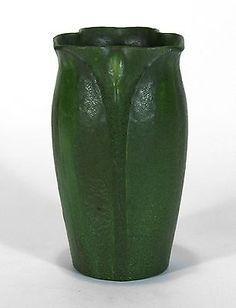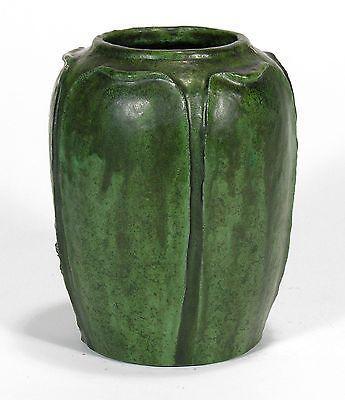The first image is the image on the left, the second image is the image on the right. Evaluate the accuracy of this statement regarding the images: "All vases are the same green color with a drip effect, and no vases have handles.". Is it true? Answer yes or no. Yes. The first image is the image on the left, the second image is the image on the right. Examine the images to the left and right. Is the description "One vase is mostly dark green while the other has a lot more lighter green on it." accurate? Answer yes or no. Yes. 